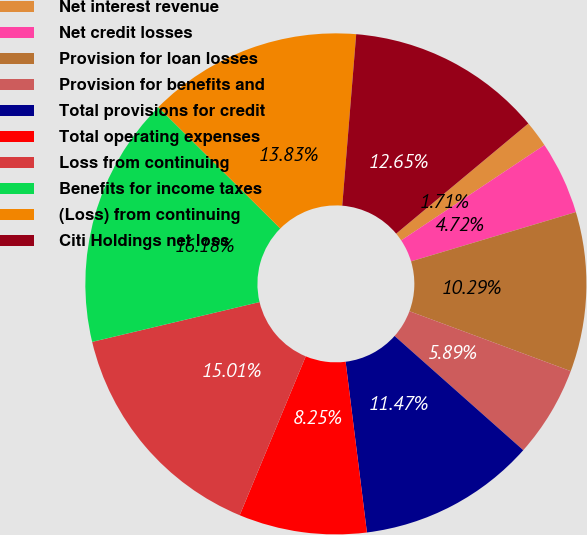Convert chart to OTSL. <chart><loc_0><loc_0><loc_500><loc_500><pie_chart><fcel>Net interest revenue<fcel>Net credit losses<fcel>Provision for loan losses<fcel>Provision for benefits and<fcel>Total provisions for credit<fcel>Total operating expenses<fcel>Loss from continuing<fcel>Benefits for income taxes<fcel>(Loss) from continuing<fcel>Citi Holdings net loss<nl><fcel>1.71%<fcel>4.72%<fcel>10.29%<fcel>5.89%<fcel>11.47%<fcel>8.25%<fcel>15.01%<fcel>16.18%<fcel>13.83%<fcel>12.65%<nl></chart> 